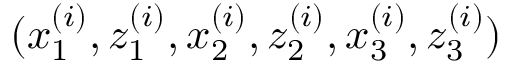<formula> <loc_0><loc_0><loc_500><loc_500>( x _ { 1 } ^ { ( i ) } , z _ { 1 } ^ { ( i ) } , x _ { 2 } ^ { ( i ) } , z _ { 2 } ^ { ( i ) } , x _ { 3 } ^ { ( i ) } , z _ { 3 } ^ { ( i ) } )</formula> 